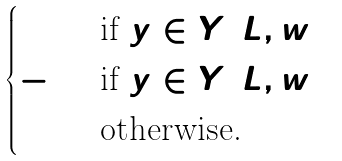<formula> <loc_0><loc_0><loc_500><loc_500>\begin{cases} 1 & \text {if } y \in Y ( L , w _ { 1 } ) \\ - 1 & \text {if } y \in Y ( L , w _ { 2 } ) \\ 0 & \text {otherwise.} \end{cases}</formula> 